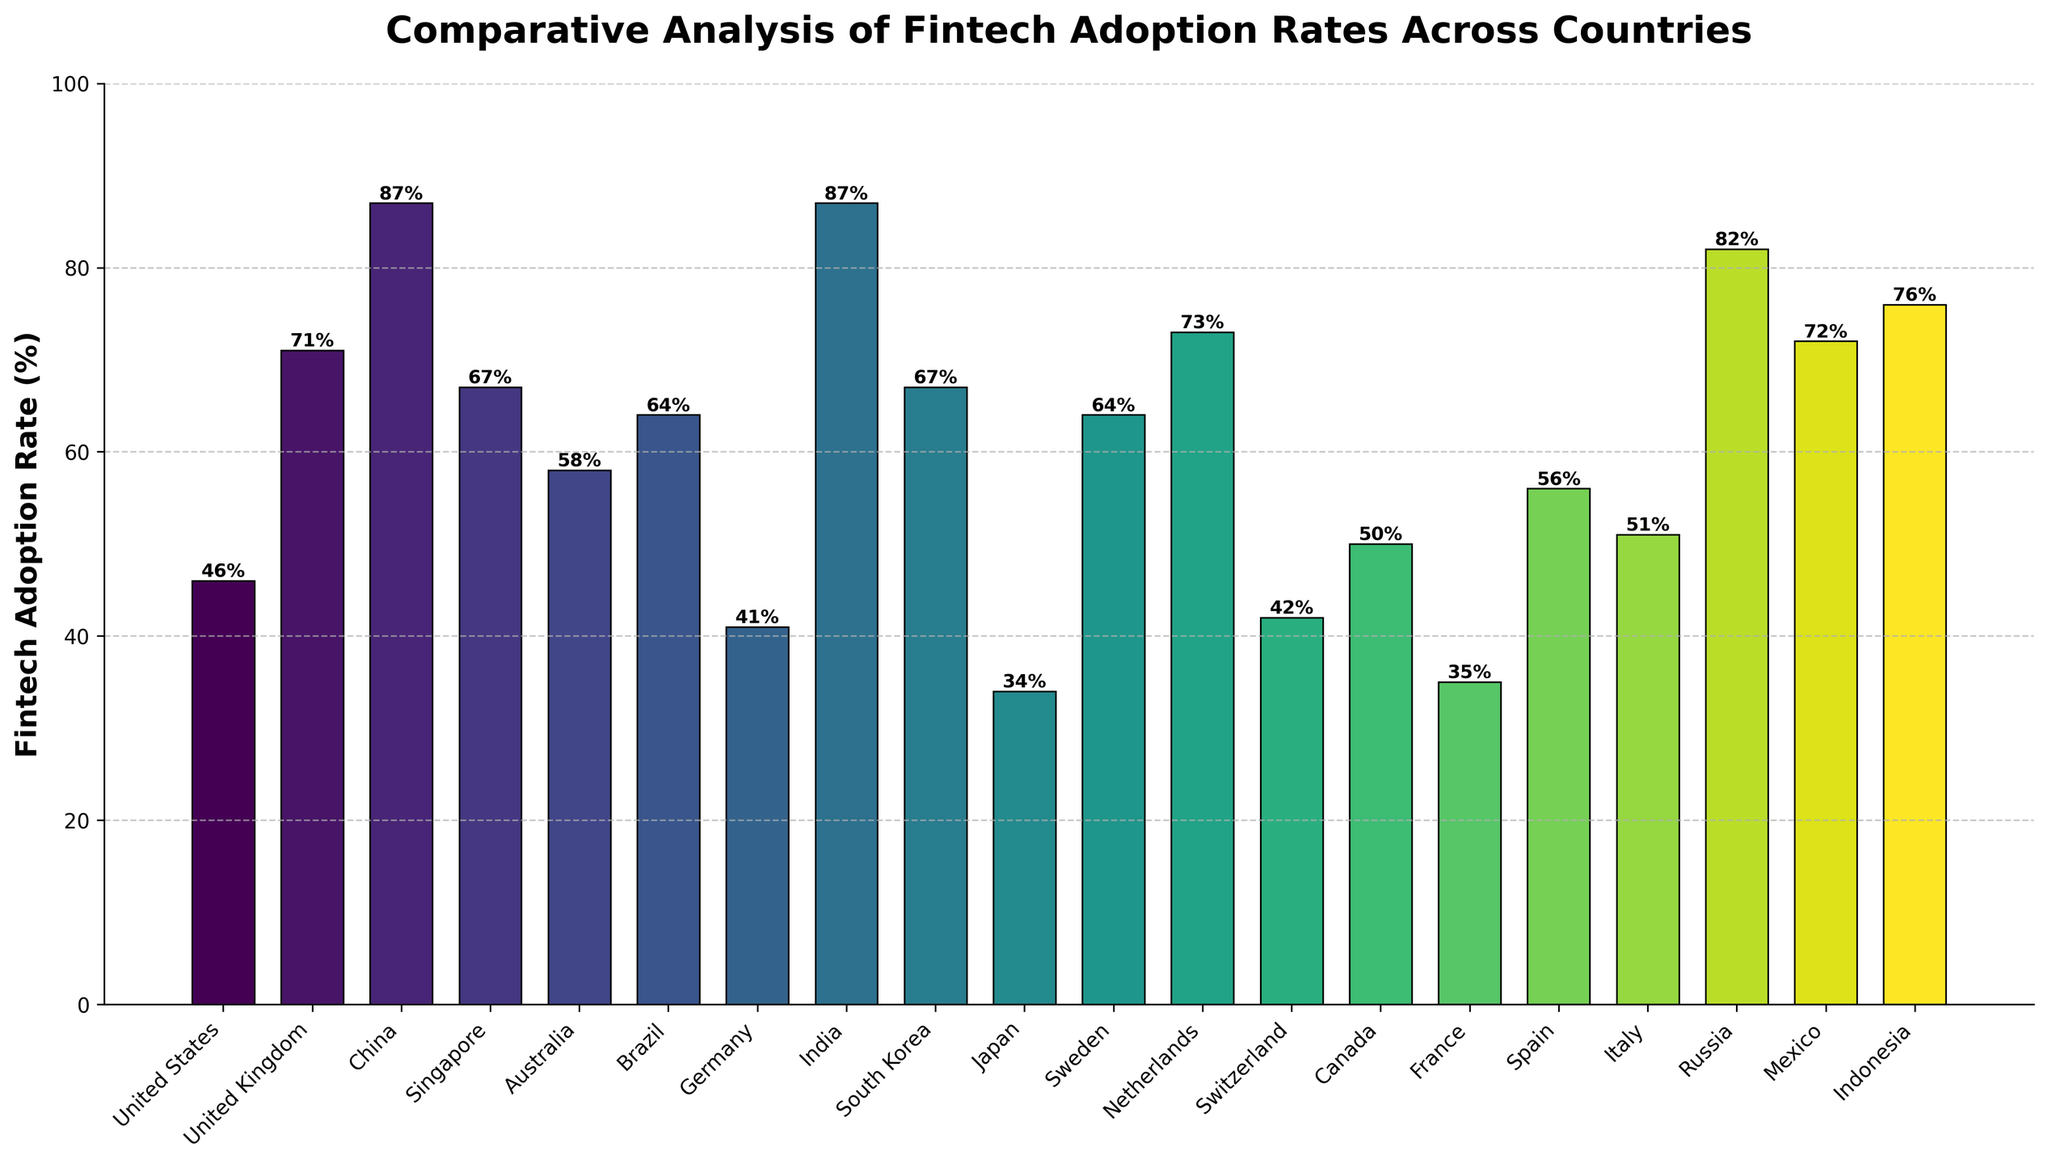Which country has the highest fintech adoption rate? By looking at the heights of the bars, the tallest bars correspond to China and India, both at 87%.
Answer: China and India Which country has the lowest fintech adoption rate? By looking at the heights of the bars, the shortest bar corresponds to Japan at 34%.
Answer: Japan What is the average fintech adoption rate of the countries with over 70% adoption? First, identify the countries with over 70% adoption: UK (71%), China (87%), Netherlands (73%), Russia (82%), Mexico (72%), Indonesia (76%), and India (87%). Add these percentages: (71 + 87 + 73 + 82 + 72 + 76 + 87) = 548. Divide by the number of countries (7): 548/7 ≈ 78.3.
Answer: 78.3% Which countries have a fintech adoption rate between 50% and 60%? Identify the bars that fall between the 50% and 60% range. These countries are Canada (50%), Italy (51%), Spain (56%), and Australia (58%).
Answer: Canada, Italy, Spain, and Australia What is the difference in fintech adoption rates between the United Kingdom and France? Find the adoption rates of both countries: United Kingdom (71%) and France (35%). Subtract France's rate from the UK's: 71% - 35% = 36%.
Answer: 36% How many countries have a fintech adoption rate above 60%? Identify the bars above the 60% mark. The countries are Brazil (64%), Sweden (64%), South Korea (67%), Singapore (67%), Mexico (72%), Indonesia (76%), Russia (82%), Netherlands (73%), UK (71%), India (87%), China (87%). Count these countries: 11.
Answer: 11 Which country has a fintech adoption rate closest to 50%? Look for the bar closest to the 50% mark. This corresponds to Canada at 50%.
Answer: Canada What is the cumulative fintech adoption rate of the countries with less than 50% adoption? Identify the countries: Japan (34%), Germany (41%), Switzerland (42%), France (35%). Add these percentages: 34 + 41 + 42 + 35 = 152.
Answer: 152% Is there a significant visual difference in fintech adoption rates between any two neighboring countries in the figure? Visually compare neighboring bars. The most significant visual difference is between China (87%) and Germany (41%). The visual height difference is substantial.
Answer: Yes, China and Germany 